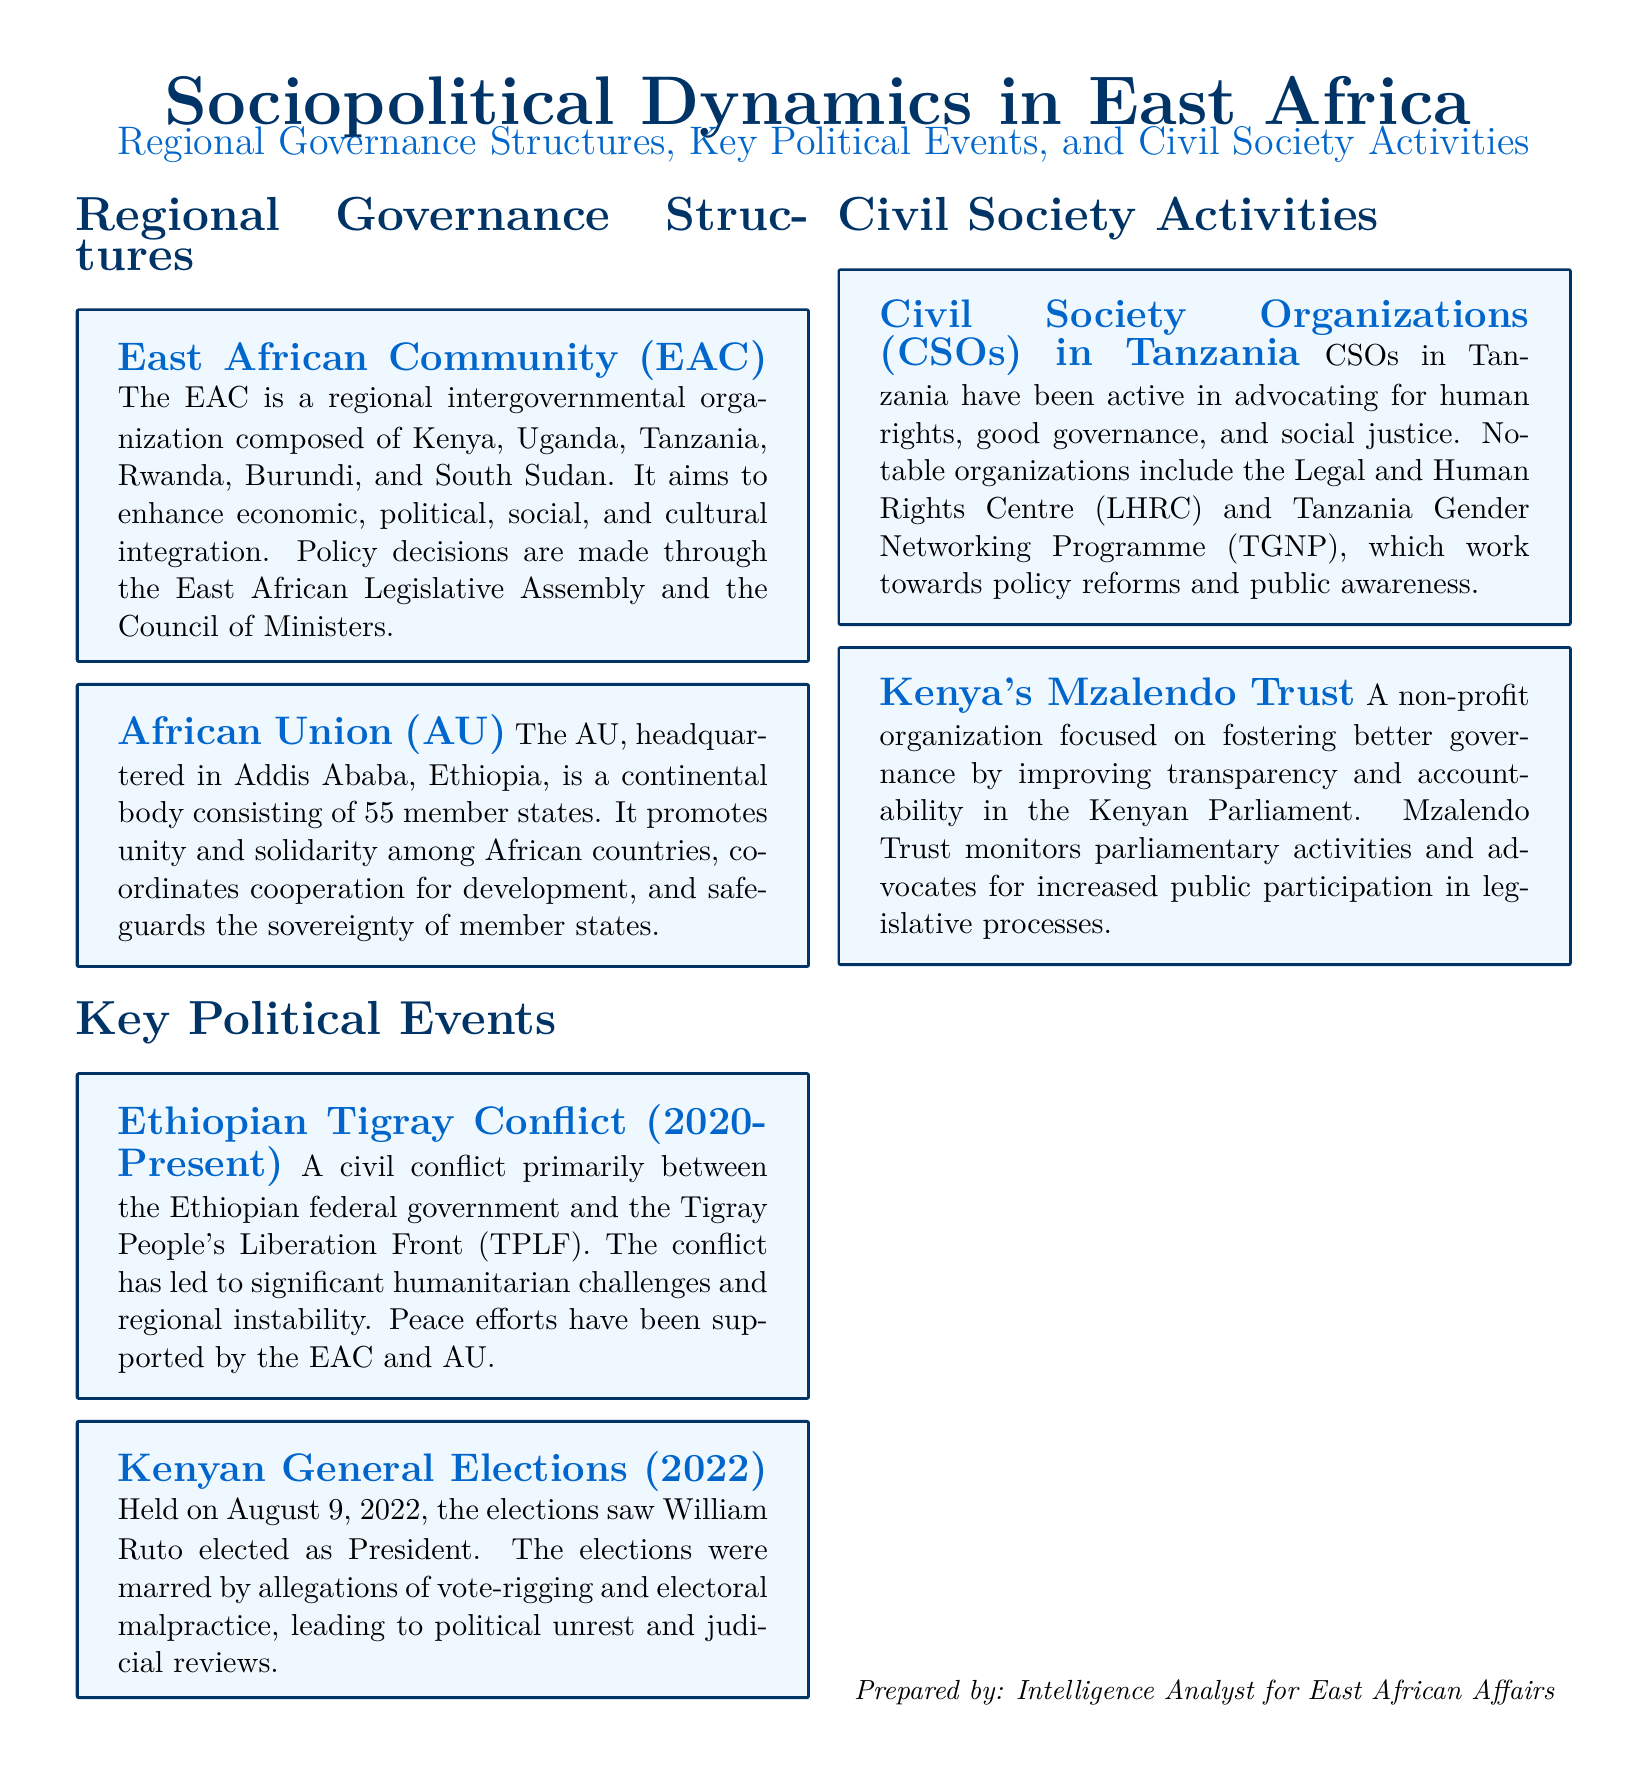what is the composition of the East African Community? The East African Community is composed of Kenya, Uganda, Tanzania, Rwanda, Burundi, and South Sudan.
Answer: Kenya, Uganda, Tanzania, Rwanda, Burundi, South Sudan where is the African Union headquartered? The African Union is headquartered in Addis Ababa, Ethiopia.
Answer: Addis Ababa, Ethiopia what key political event occurred in Kenya in 2022? The key political event in Kenya in 2022 was the general elections.
Answer: general elections who was elected as President of Kenya in 2022? William Ruto was elected as President during the Kenyan general elections in 2022.
Answer: William Ruto what conflict is noted in the document as ongoing since 2020? The Ethiopian Tigray Conflict is noted in the document as ongoing since 2020.
Answer: Ethiopian Tigray Conflict which Tanzanian organization focuses on human rights? The Legal and Human Rights Centre (LHRC) focuses on human rights in Tanzania.
Answer: Legal and Human Rights Centre what is the mission of Kenya's Mzalendo Trust? Mzalendo Trust aims to enhance transparency and accountability in the Kenyan Parliament.
Answer: transparency and accountability which regional organization coordinates peace efforts regarding the Ethiopian Tigray Conflict? Both the East African Community and the African Union support peace efforts regarding the Ethiopian Tigray Conflict.
Answer: East African Community and African Union 